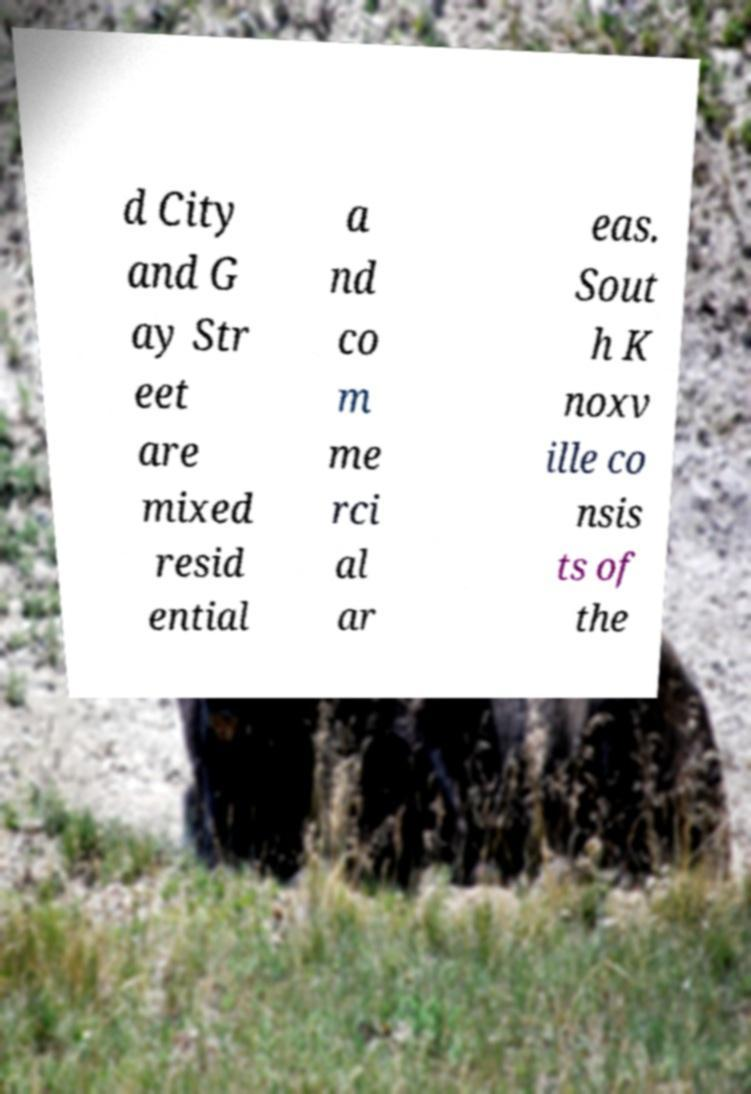Please identify and transcribe the text found in this image. d City and G ay Str eet are mixed resid ential a nd co m me rci al ar eas. Sout h K noxv ille co nsis ts of the 